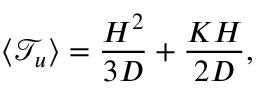<formula> <loc_0><loc_0><loc_500><loc_500>\langle \mathcal { T } _ { u } \rangle = \frac { H ^ { 2 } } { 3 D } + \frac { K H } { 2 D } ,</formula> 